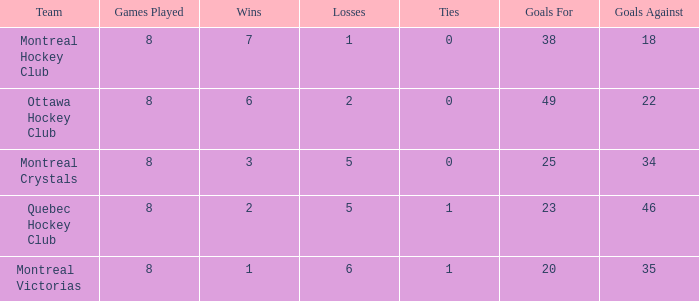When there are fewer than 34 goals allowed and fewer than 8 games played, what is the combined total of losses? None. 